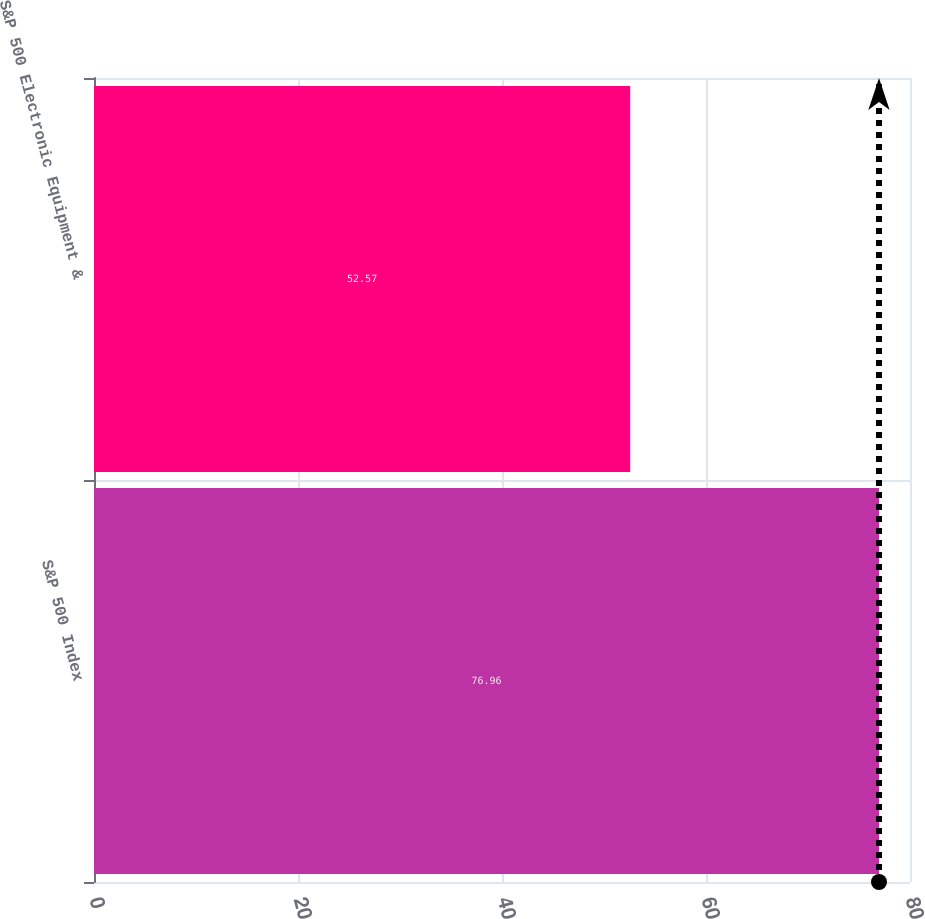Convert chart to OTSL. <chart><loc_0><loc_0><loc_500><loc_500><bar_chart><fcel>S&P 500 Index<fcel>S&P 500 Electronic Equipment &<nl><fcel>76.96<fcel>52.57<nl></chart> 